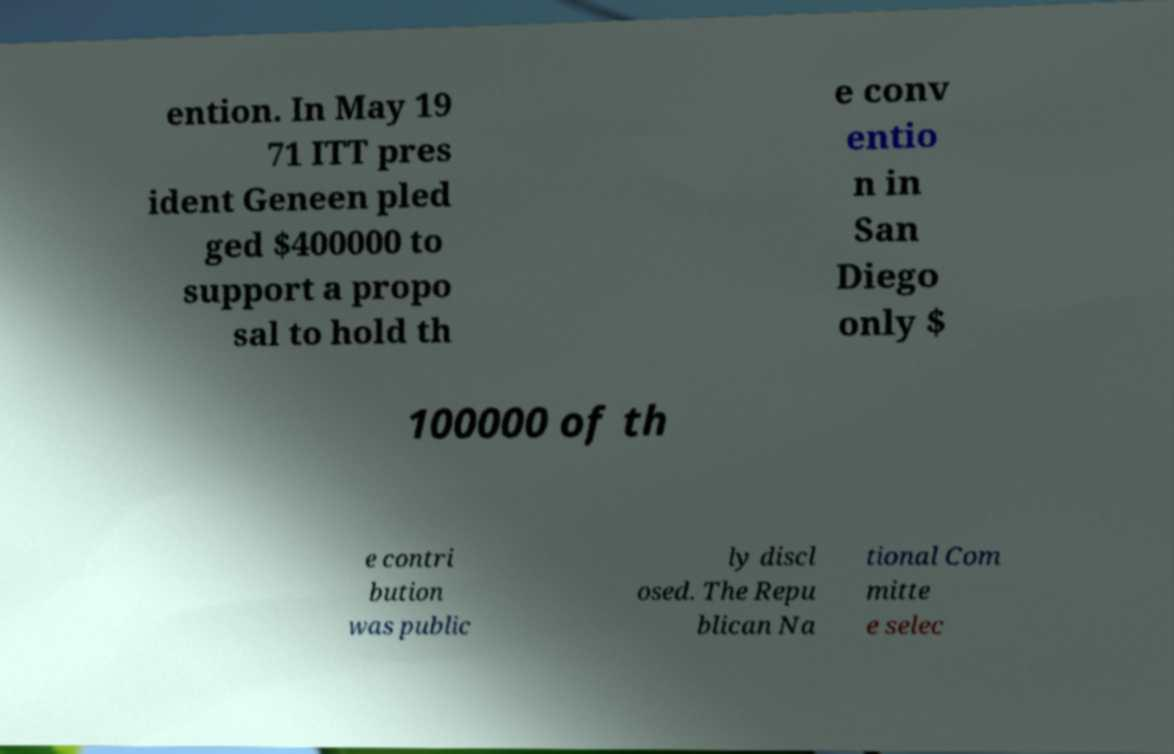I need the written content from this picture converted into text. Can you do that? ention. In May 19 71 ITT pres ident Geneen pled ged $400000 to support a propo sal to hold th e conv entio n in San Diego only $ 100000 of th e contri bution was public ly discl osed. The Repu blican Na tional Com mitte e selec 